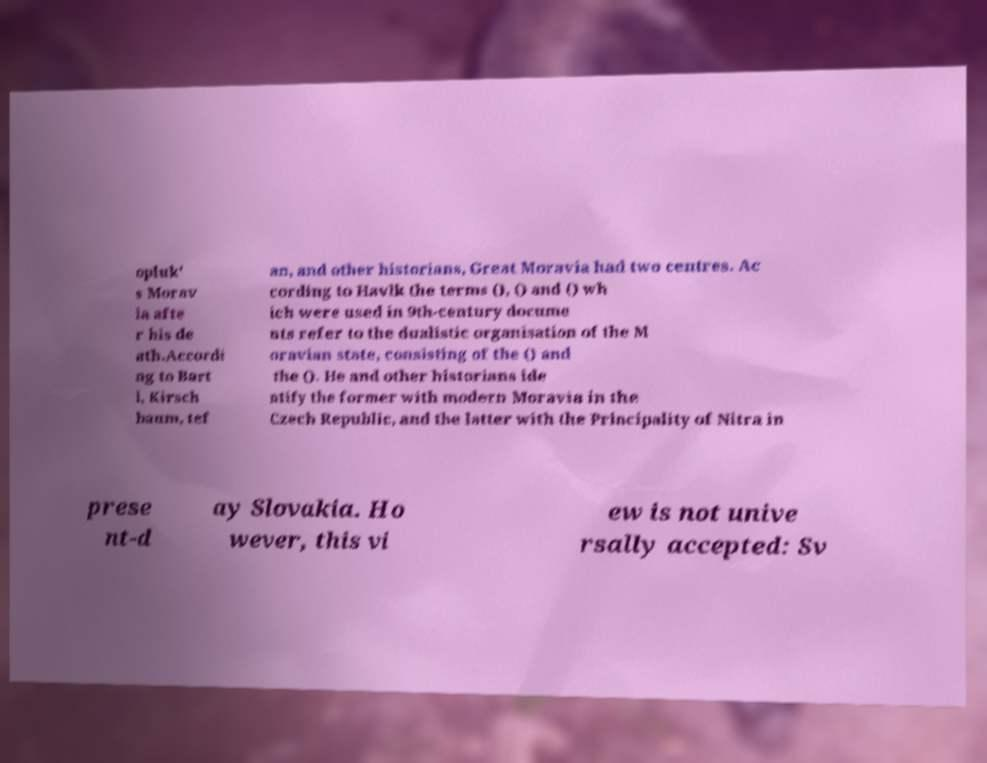I need the written content from this picture converted into text. Can you do that? opluk' s Morav ia afte r his de ath.Accordi ng to Bart l, Kirsch baum, tef an, and other historians, Great Moravia had two centres. Ac cording to Havlk the terms (), () and () wh ich were used in 9th-century docume nts refer to the dualistic organisation of the M oravian state, consisting of the () and the (). He and other historians ide ntify the former with modern Moravia in the Czech Republic, and the latter with the Principality of Nitra in prese nt-d ay Slovakia. Ho wever, this vi ew is not unive rsally accepted: Sv 